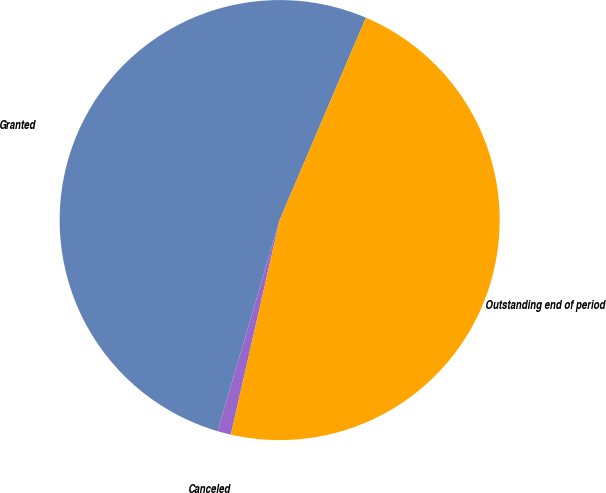Convert chart. <chart><loc_0><loc_0><loc_500><loc_500><pie_chart><fcel>Granted<fcel>Canceled<fcel>Outstanding end of period<nl><fcel>51.86%<fcel>0.99%<fcel>47.15%<nl></chart> 